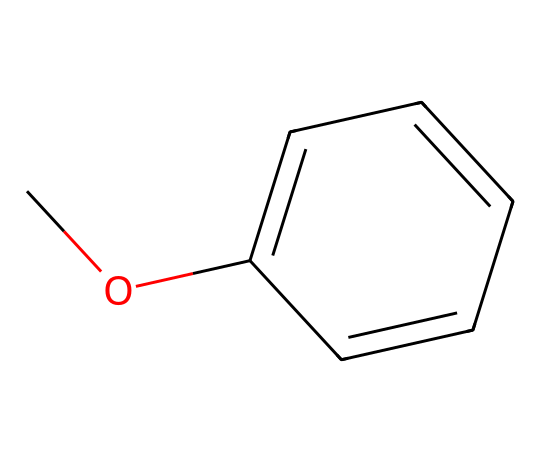What is the common name of this chemical? The SMILES representation COc1ccccc1 corresponds to a structure commonly known as anisole. This name is derived from its phenolic nature with an ether functional group attached to the aromatic ring.
Answer: anisole How many carbon atoms are present in anisole? From the SMILES, we see 'c' indicating carbon atoms in the aromatic ring as well as 'C' for the methyl group. Counting all, there are a total of 8 carbon atoms in the structure.
Answer: 8 What type of functional group is present in anisole? The structure contains an ether functional group as indicated by the 'O' separating the carbon chains. Ethers are characterized by an oxygen atom bonded to two alkyl or aryl groups.
Answer: ether What is the primary aromatic structure in anisole? The 'c1ccccc1' in the SMILES indicates that the primary structure is a benzene ring, which is the aromatic component of anisole, consisting of six carbon atoms arranged in a cyclic structure with alternating double bonds.
Answer: benzene What type of bonding is present between the carbon and the oxygen in anisole? In anisole, the carbon and oxygen are connected by a single bond, typical of ethers. This bond allows for the connectivity of the methyl group to the aromatic ring through the oxygen atom.
Answer: single bond How many hydrogen atoms are connected to the carbon atoms in anisole? Counting the hydrogen atoms attached to each carbon in the structure, we find that there are 8 hydrogen atoms in total surrounding the carbon framework of the molecule.
Answer: 8 